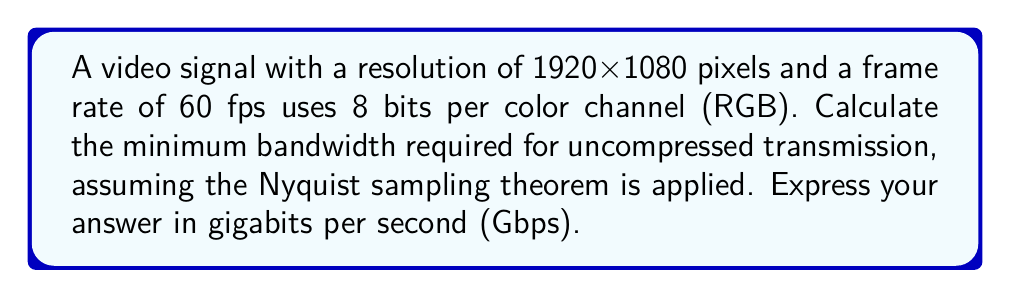Can you solve this math problem? Let's approach this step-by-step:

1) First, calculate the total number of pixels per frame:
   $1920 \times 1080 = 2,073,600$ pixels/frame

2) Each pixel has 3 color channels (RGB), and each channel uses 8 bits:
   $8 \text{ bits} \times 3 = 24$ bits/pixel

3) Calculate bits per frame:
   $2,073,600 \text{ pixels/frame} \times 24 \text{ bits/pixel} = 49,766,400$ bits/frame

4) Multiply by the frame rate to get bits per second:
   $49,766,400 \text{ bits/frame} \times 60 \text{ fps} = 2,985,984,000$ bits/second

5) Convert to gigabits per second:
   $\frac{2,985,984,000}{10^9} = 2.985984$ Gbps

6) The Nyquist sampling theorem states that the sampling rate must be at least twice the highest frequency component. In digital video, this translates to doubling the calculated bandwidth:
   $2.985984 \times 2 = 5.971968$ Gbps

Therefore, the minimum bandwidth required is approximately 5.97 Gbps.
Answer: 5.97 Gbps 